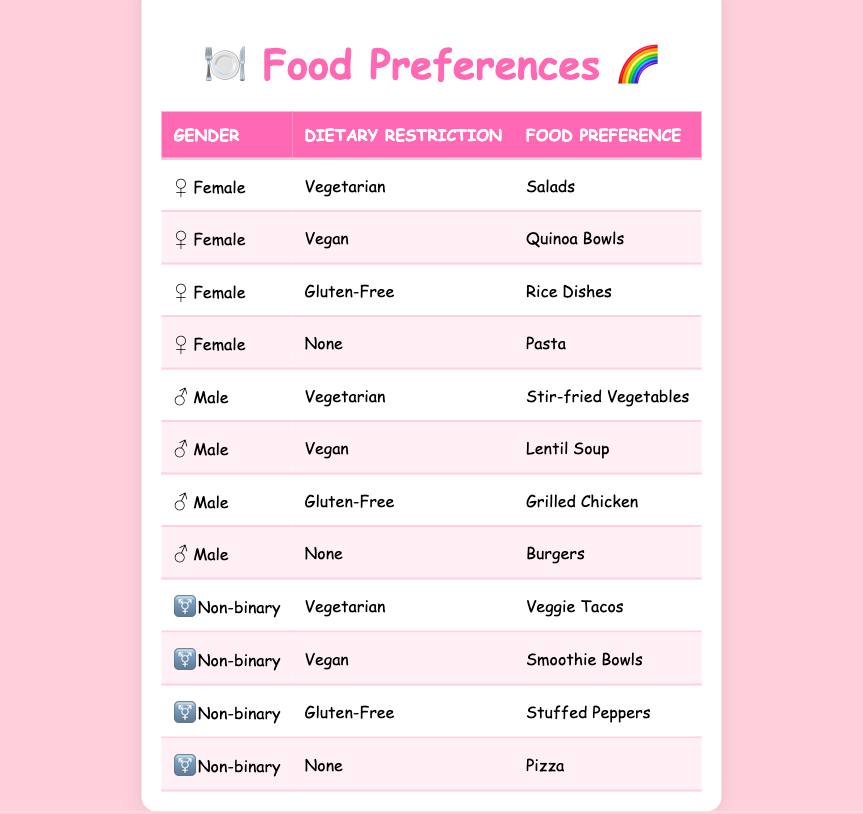What food preference do females with a vegan dietary restriction have? In the table, we look for the row where the gender is Female and the dietary restriction is Vegan. The food preference listed in that row is Quinoa Bowls.
Answer: Quinoa Bowls How many different food preferences are listed for males? The table has four entries for males, each with a different food preference: Stir-fried Vegetables, Lentil Soup, Grilled Chicken, and Burgers. Therefore, there are four unique food preferences for males.
Answer: 4 Is there any food preference listed for non-binary individuals that contains meat? Looking through the food preferences for non-binary individuals, we see Veggie Tacos, Smoothie Bowls, Stuffed Peppers, and Pizza. None of these contain meat, so the answer is no.
Answer: No Which gender has a food preference for Rice Dishes? We scan the table for the food preference Rice Dishes. The corresponding row shows that this preference is found under the Female gender.
Answer: Female What is the combined total of unique food preferences for all genders? From the table, we identify the unique food preferences: Salads, Quinoa Bowls, Rice Dishes, Pasta, Stir-fried Vegetables, Lentil Soup, Grilled Chicken, Burgers, Veggie Tacos, Smoothie Bowls, Stuffed Peppers, and Pizza. Counting these gives us a total of 12 unique food preferences.
Answer: 12 Do male individuals have a preference for vegetarian food? Checking the table, we find that males do have a preference for vegetarian food, as one of the entries is Stir-fried Vegetables, which is a vegetarian option.
Answer: Yes How many food preferences do non-binary individuals have under a gluten-free dietary restriction? Looking for the non-binary entries with a gluten-free dietary restriction, there is one preference listed: Stuffed Peppers. Thus, the count is one.
Answer: 1 Which food preference is most represented by gender? We analyze the number of entries for each gender: Females (4), Males (4), and Non-binary (4) all have the same total. Hence, there is no clear most represented gender as they are all equal.
Answer: All equal 